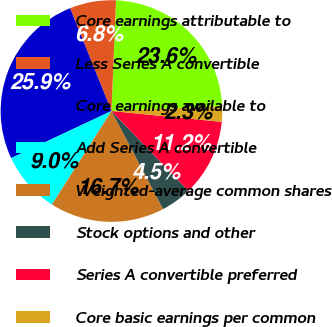Convert chart. <chart><loc_0><loc_0><loc_500><loc_500><pie_chart><fcel>Core earnings attributable to<fcel>Less Series A convertible<fcel>Core earnings available to<fcel>Add Series A convertible<fcel>Weighted-average common shares<fcel>Stock options and other<fcel>Series A convertible preferred<fcel>Core basic earnings per common<nl><fcel>23.65%<fcel>6.75%<fcel>25.89%<fcel>8.99%<fcel>16.73%<fcel>4.5%<fcel>11.23%<fcel>2.26%<nl></chart> 